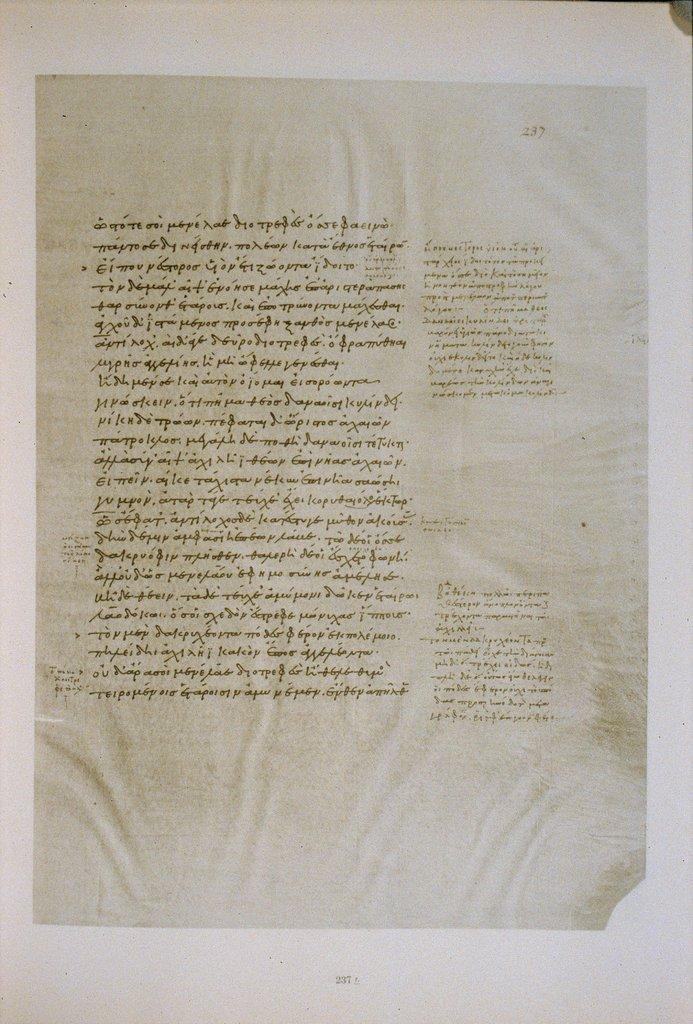What is the page number?
Your response must be concise. 237. 